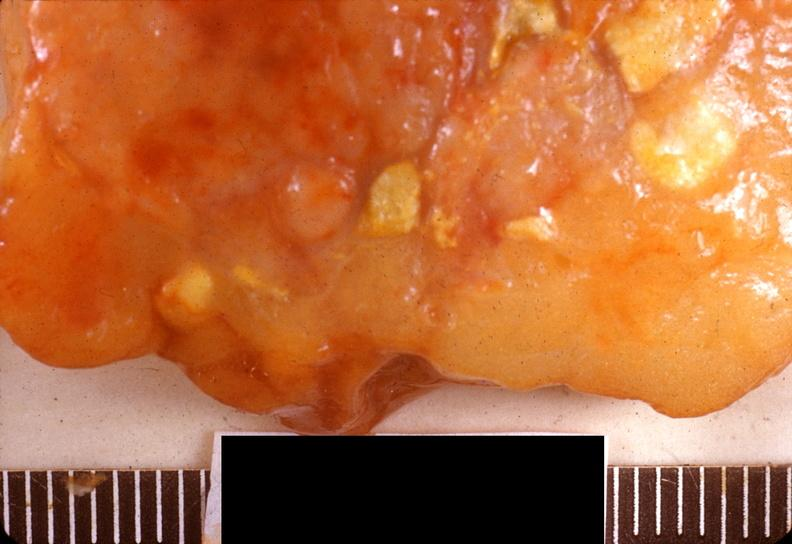does mucicarmine show acute pancreatitis?
Answer the question using a single word or phrase. No 